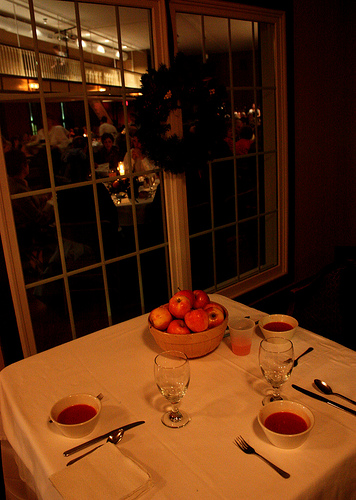<image>
Is there a apple next to the soup? Yes. The apple is positioned adjacent to the soup, located nearby in the same general area. 